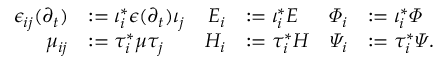<formula> <loc_0><loc_0><loc_500><loc_500>\begin{array} { r l r l r l } { \epsilon _ { i j } ( \partial _ { t } ) } & { \mathop \colon = \iota _ { i } ^ { * } \epsilon ( \partial _ { t } ) \iota _ { j } } & { E _ { i } } & { \mathop \colon = \iota _ { i } ^ { * } E } & { \varPhi _ { i } } & { \mathop \colon = \iota _ { i } ^ { * } \varPhi } \\ { \mu _ { i j } } & { \mathop \colon = \tau _ { i } ^ { * } \mu \tau _ { j } } & { H _ { i } } & { \mathop \colon = \tau _ { i } ^ { * } H } & { \varPsi _ { i } } & { \mathop \colon = \tau _ { i } ^ { * } \varPsi . } \end{array}</formula> 